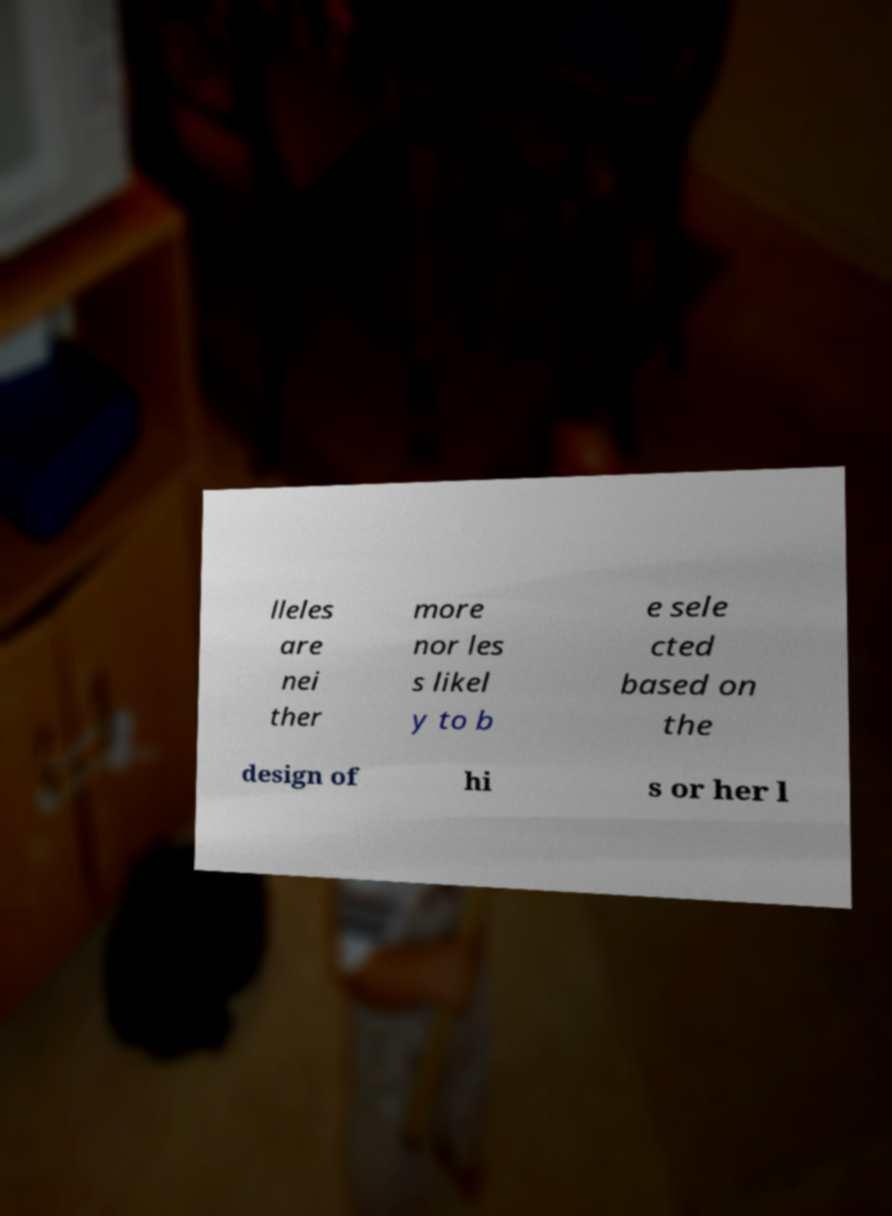There's text embedded in this image that I need extracted. Can you transcribe it verbatim? lleles are nei ther more nor les s likel y to b e sele cted based on the design of hi s or her l 